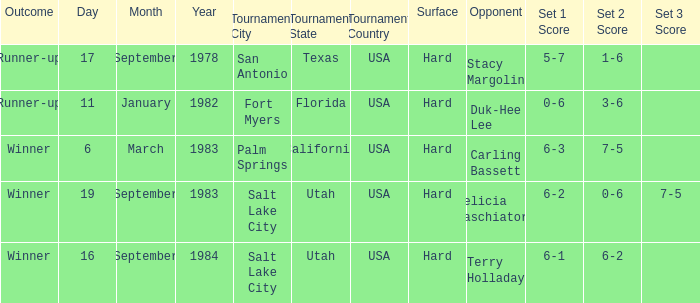Help me parse the entirety of this table. {'header': ['Outcome', 'Day', 'Month', 'Year', 'Tournament City', 'Tournament State', 'Tournament Country', 'Surface', 'Opponent', 'Set 1 Score', 'Set 2 Score', 'Set 3 Score'], 'rows': [['Runner-up', '17', 'September', '1978', 'San Antonio', 'Texas', 'USA', 'Hard', 'Stacy Margolin', '5-7', '1-6', ''], ['Runner-up', '11', 'January', '1982', 'Fort Myers', 'Florida', 'USA', 'Hard', 'Duk-Hee Lee', '0-6', '3-6', ''], ['Winner', '6', 'March', '1983', 'Palm Springs', 'California', 'USA', 'Hard', 'Carling Bassett', '6-3', '7-5', ''], ['Winner', '19', 'September', '1983', 'Salt Lake City', 'Utah', 'USA', 'Hard', 'Felicia Raschiatore', '6-2', '0-6', '7-5'], ['Winner', '16', 'September', '1984', 'Salt Lake City', 'Utah', 'USA', 'Hard', 'Terry Holladay', '6-1', '6-2', '']]} Who was the opponent for the match were the outcome was runner-up and the score was 5-7, 1-6? Stacy Margolin. 